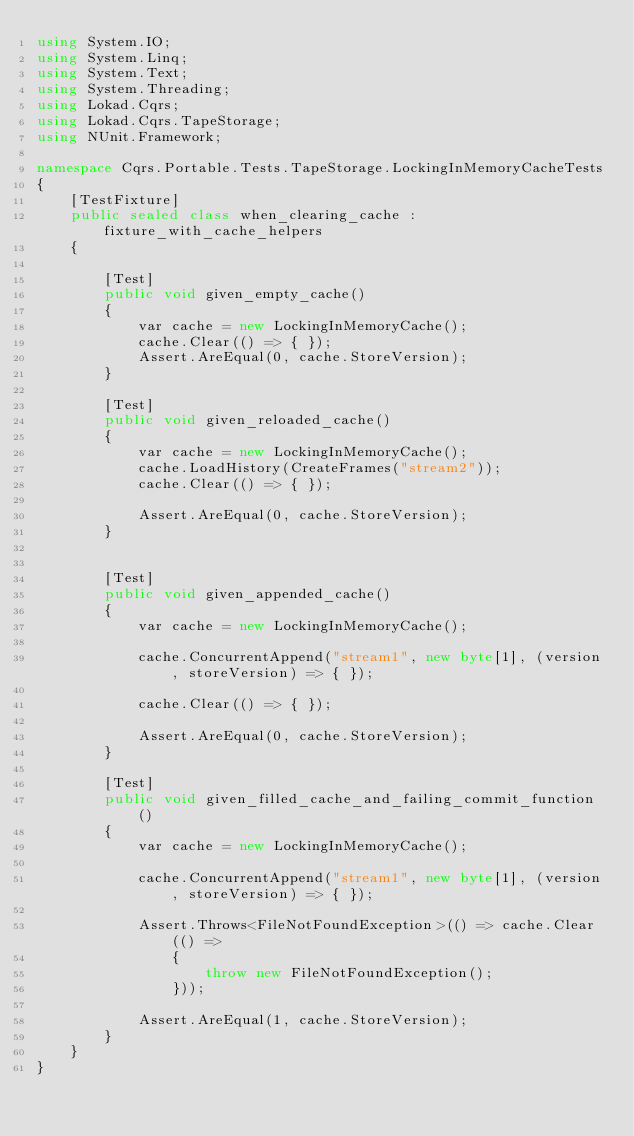<code> <loc_0><loc_0><loc_500><loc_500><_C#_>using System.IO;
using System.Linq;
using System.Text;
using System.Threading;
using Lokad.Cqrs;
using Lokad.Cqrs.TapeStorage;
using NUnit.Framework;

namespace Cqrs.Portable.Tests.TapeStorage.LockingInMemoryCacheTests
{
    [TestFixture]
    public sealed class when_clearing_cache : fixture_with_cache_helpers
    {

        [Test]
        public void given_empty_cache()
        {
            var cache = new LockingInMemoryCache();
            cache.Clear(() => { });
            Assert.AreEqual(0, cache.StoreVersion);
        }

        [Test]
        public void given_reloaded_cache()
        {
            var cache = new LockingInMemoryCache();
            cache.LoadHistory(CreateFrames("stream2"));
            cache.Clear(() => { });

            Assert.AreEqual(0, cache.StoreVersion);
        }


        [Test]
        public void given_appended_cache()
        {
            var cache = new LockingInMemoryCache();

            cache.ConcurrentAppend("stream1", new byte[1], (version, storeVersion) => { });

            cache.Clear(() => { });

            Assert.AreEqual(0, cache.StoreVersion);
        }

        [Test]
        public void given_filled_cache_and_failing_commit_function()
        {
            var cache = new LockingInMemoryCache();

            cache.ConcurrentAppend("stream1", new byte[1], (version, storeVersion) => { });

            Assert.Throws<FileNotFoundException>(() => cache.Clear(() =>
                {
                    throw new FileNotFoundException();
                }));

            Assert.AreEqual(1, cache.StoreVersion);
        }
    }
}</code> 